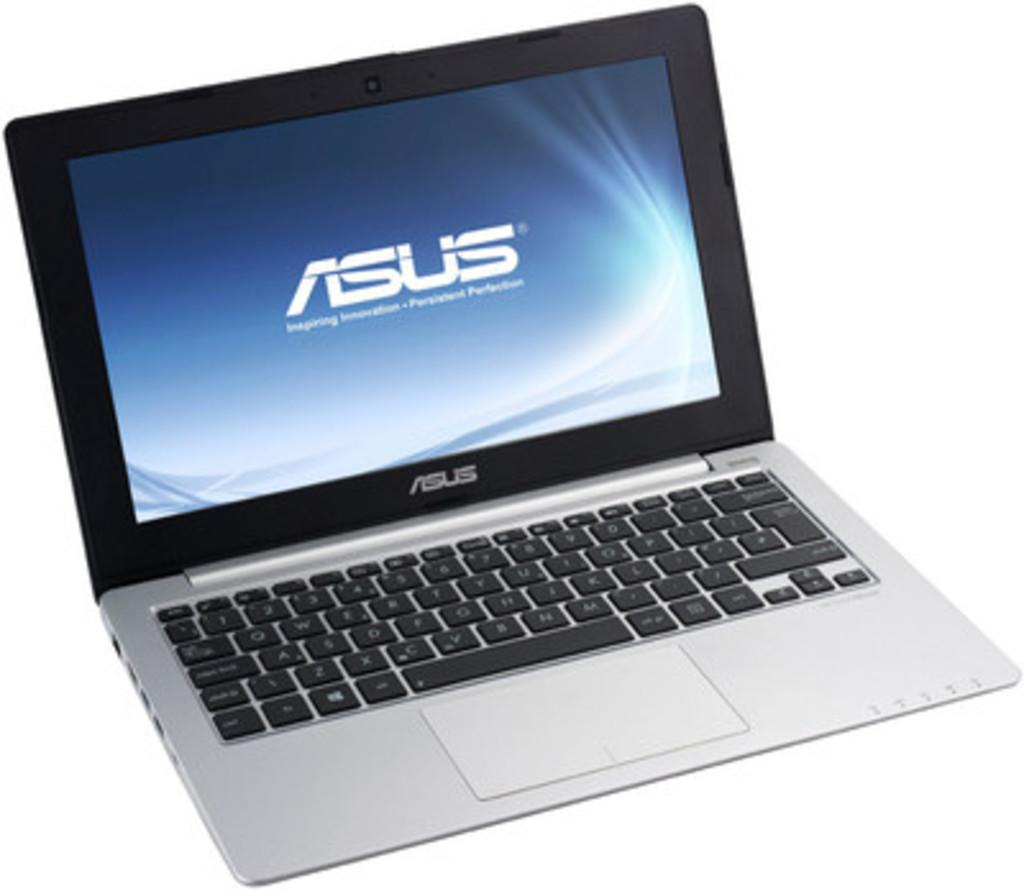<image>
Provide a brief description of the given image. the word Asus is on the blue screen of the laptop 